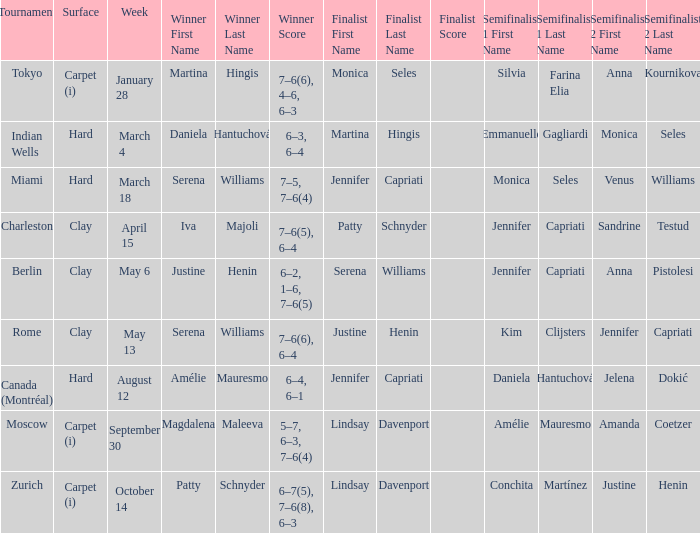Who emerged triumphant in the indian wells? Daniela Hantuchová 6–3, 6–4. 